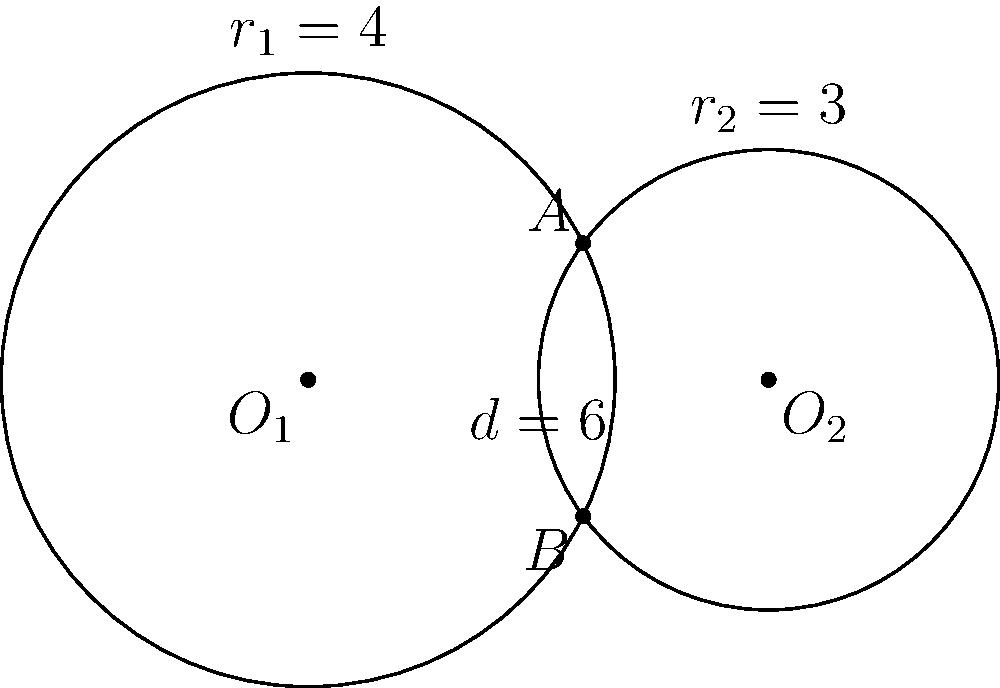In your latest creative pitch, you've proposed a revolutionary set design featuring two intersecting circular stages. As a competing network director, I'm skeptical about the feasibility. Let's break it down mathematically: Two circles with centers $O_1$ and $O_2$ have radii 4 and 3 units respectively, and their centers are 6 units apart. How many intersection points do these circles have? Justify your answer using the distance between centers and the sum and difference of radii. Let's approach this step-by-step:

1) First, we need to recall the conditions for circle intersections:
   - If $d > r_1 + r_2$, the circles don't intersect (0 points)
   - If $d = r_1 + r_2$, the circles are tangent externally (1 point)
   - If $|r_1 - r_2| < d < r_1 + r_2$, the circles intersect at 2 points
   - If $d = |r_1 - r_2|$, the circles are tangent internally (1 point)
   - If $d < |r_1 - r_2|$, one circle is inside the other (0 points)

2) In this case:
   $r_1 = 4$, $r_2 = 3$, and $d = 6$

3) Let's calculate:
   $r_1 + r_2 = 4 + 3 = 7$
   $|r_1 - r_2| = |4 - 3| = 1$

4) Now, we can see that:
   $|r_1 - r_2| < d < r_1 + r_2$
   $1 < 6 < 7$

5) This satisfies the condition for two intersection points.

Therefore, the circles intersect at 2 points.
Answer: 2 intersection points 